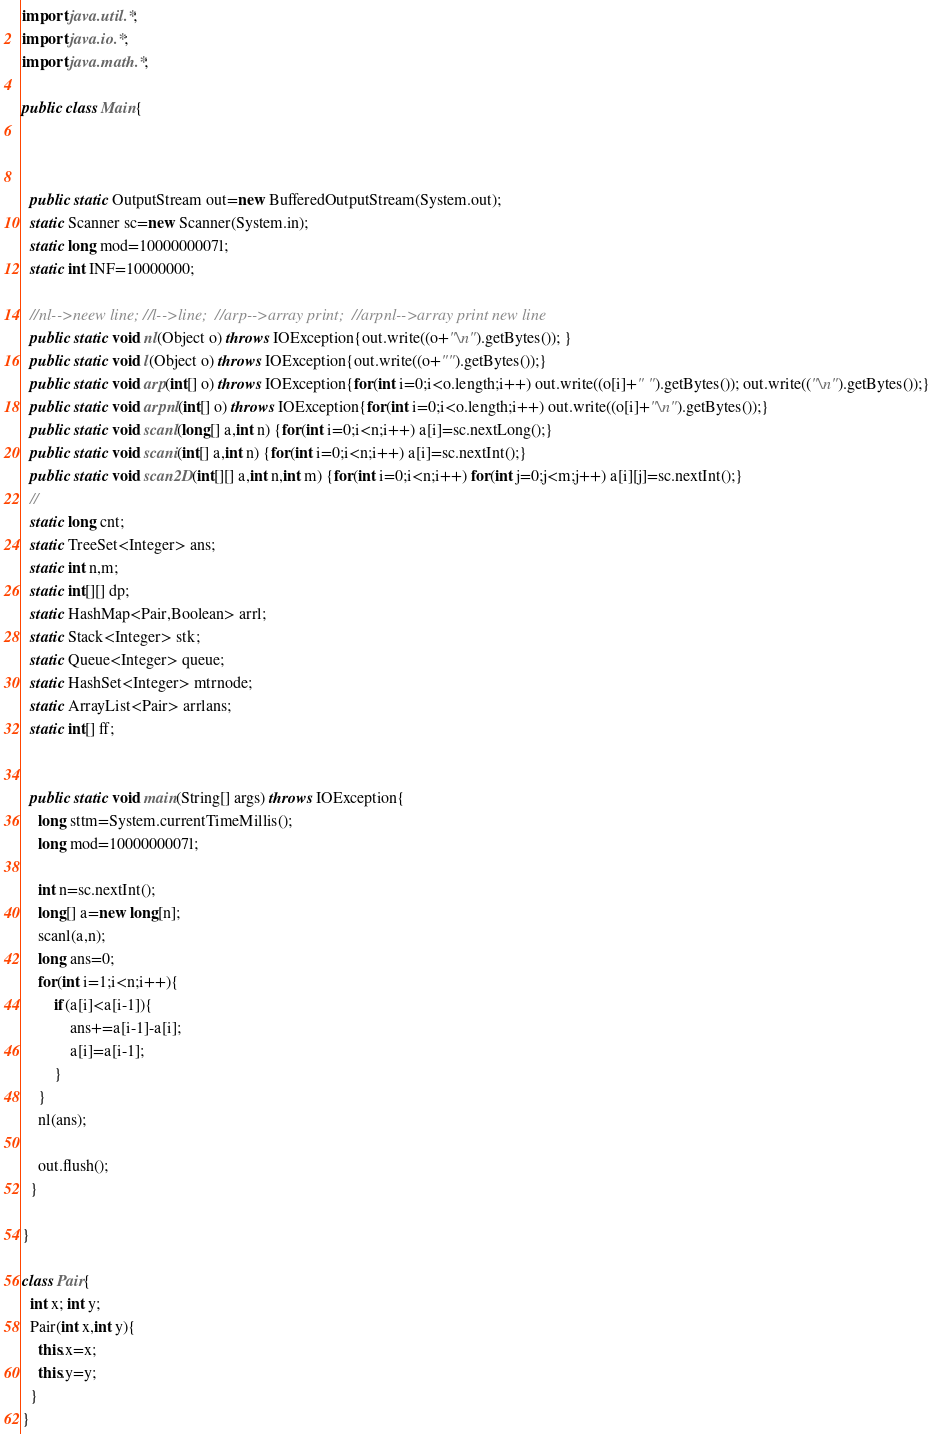Convert code to text. <code><loc_0><loc_0><loc_500><loc_500><_Java_>import java.util.*;
import java.io.*;
import java.math.*;

public class Main{



  public static OutputStream out=new BufferedOutputStream(System.out);
  static Scanner sc=new Scanner(System.in);
  static long mod=1000000007l;
  static int INF=10000000;

  //nl-->neew line; //l-->line;  //arp-->array print;  //arpnl-->array print new line
  public static void nl(Object o) throws IOException{out.write((o+"\n").getBytes()); }
  public static void l(Object o) throws IOException{out.write((o+"").getBytes());}
  public static void arp(int[] o) throws IOException{for(int i=0;i<o.length;i++) out.write((o[i]+" ").getBytes()); out.write(("\n").getBytes());}
  public static void arpnl(int[] o) throws IOException{for(int i=0;i<o.length;i++) out.write((o[i]+"\n").getBytes());}
  public static void scanl(long[] a,int n) {for(int i=0;i<n;i++) a[i]=sc.nextLong();}
  public static void scani(int[] a,int n) {for(int i=0;i<n;i++) a[i]=sc.nextInt();}
  public static void scan2D(int[][] a,int n,int m) {for(int i=0;i<n;i++) for(int j=0;j<m;j++) a[i][j]=sc.nextInt();}
  //
  static long cnt;
  static TreeSet<Integer> ans;
  static int n,m;
  static int[][] dp;
  static HashMap<Pair,Boolean> arrl;
  static Stack<Integer> stk;
  static Queue<Integer> queue;
  static HashSet<Integer> mtrnode;
  static ArrayList<Pair> arrlans;
  static int[] ff;


  public static void main(String[] args) throws IOException{
    long sttm=System.currentTimeMillis();
    long mod=1000000007l;

    int n=sc.nextInt();
    long[] a=new long[n];
    scanl(a,n);
    long ans=0;
    for(int i=1;i<n;i++){
        if(a[i]<a[i-1]){
            ans+=a[i-1]-a[i];
            a[i]=a[i-1];
        }
    }
    nl(ans);

    out.flush();
  }

}

class Pair{
  int x; int y;
  Pair(int x,int y){
    this.x=x;
    this.y=y;
  }
}
</code> 